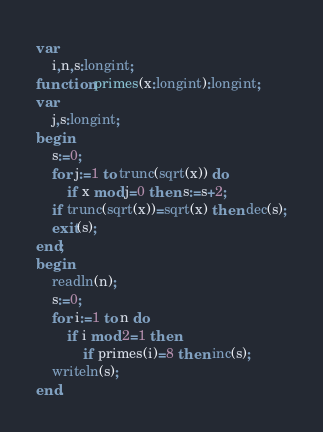<code> <loc_0><loc_0><loc_500><loc_500><_Pascal_>var
	i,n,s:longint;
function primes(x:longint):longint;
var
	j,s:longint;
begin
	s:=0;
	for j:=1 to trunc(sqrt(x)) do
		if x mod j=0 then s:=s+2;
	if trunc(sqrt(x))=sqrt(x) then dec(s);
	exit(s);
end;
begin
	readln(n);
	s:=0;
	for i:=1 to n do
		if i mod 2=1 then
			if primes(i)=8 then inc(s);
	writeln(s);
end.</code> 